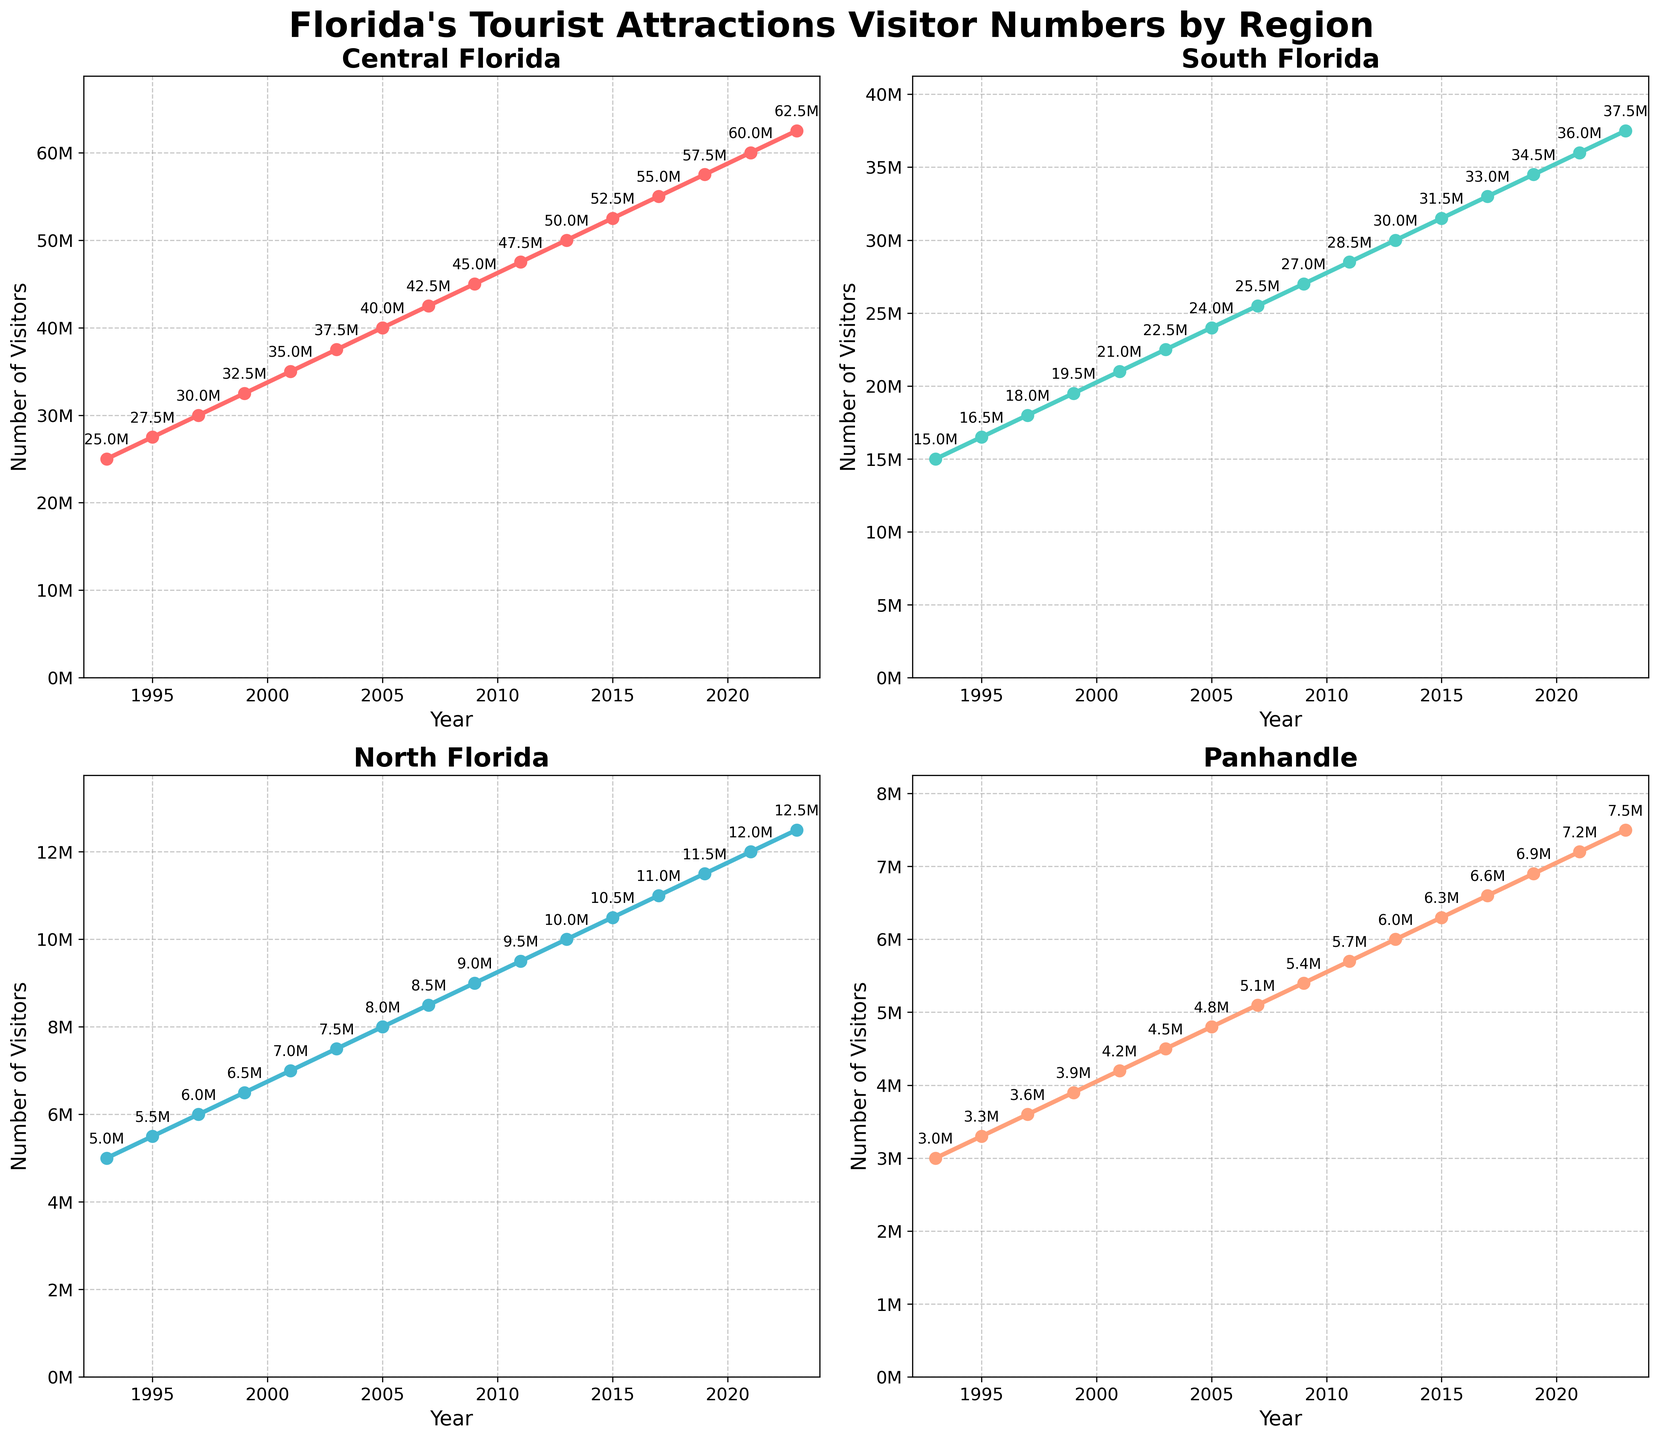What's the total number of visitors across all regions in 2023? To find the total number of visitors in 2023, add the visitor numbers of all four regions: Central Florida (62,500,000), South Florida (37,500,000), North Florida (12,500,000), and Panhandle (7,500,000). So, 62,500,000 + 37,500,000 + 12,500,000 + 7,500,000 = 120,000,000.
Answer: 120,000,000 In which year did Central Florida first reach 50 million visitors? Look at the plot for Central Florida and identify the year where the visitor count first reached 50 million. The plot shows that in 2013, visitor numbers reached 50 million.
Answer: 2013 Which region had the least number of visitors in 2009? Compare the visitor numbers for all regions in 2009. Central Florida had 45 million visitors, South Florida had 27 million, North Florida had 9 million, and Panhandle had 5.4 million. The Panhandle had the least number of visitors.
Answer: Panhandle By how much did the visitor numbers in South Florida increase from 1997 to 2003? To find the increase, subtract the number of visitors in 1997 from the number in 2003 for South Florida: 22,500,000 - 18,000,000 = 4,500,000.
Answer: 4,500,000 What's the average annual increase in visitors for North Florida from 1993 to 2023? The total increase over 30 years (1993 to 2023) for North Florida is 12,500,000 - 5,000,000 = 7,500,000. The average annual increase is 7,500,000 / 30 = 250,000.
Answer: 250,000 Compare the visitor trends: Which region showed the most steady growth over the entire period? Observing the plots, Central Florida shows the most consistent and steady growth, with a linear increase in visitor numbers over the years.
Answer: Central Florida Which year showed the highest increase in visitors for Central Florida between consecutive data points? To find this, look at the increases between consecutive years. The largest increase for Central Florida is between 2001 (35,000,000) and 2003 (37,500,000), where the increase is 2,500,000.
Answer: 2001-2003 How does the visitor number in the Panhandle in 2019 compare to that in North Florida in 2021? The visitor number in the Panhandle in 2019 is 6,900,000, and for North Florida in 2021, it is 12,000,000. North Florida in 2021 had significantly more visitors.
Answer: North Florida had more in 2021 Visualize and name the regions by their growth color: red, green, blue, and salmon. Look at the plot colors: Central Florida is marked in red, South Florida in green, North Florida in blue, and Panhandle in salmon.
Answer: Central Florida: red, South Florida: green, North Florida: blue, Panhandle: salmon 